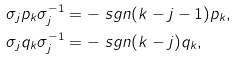<formula> <loc_0><loc_0><loc_500><loc_500>\sigma _ { j } p _ { k } \sigma _ { j } ^ { - 1 } & = - \ s g n ( k - j - 1 ) p _ { k } , \\ \sigma _ { j } q _ { k } \sigma _ { j } ^ { - 1 } & = - \ s g n ( k - j ) q _ { k } ,</formula> 